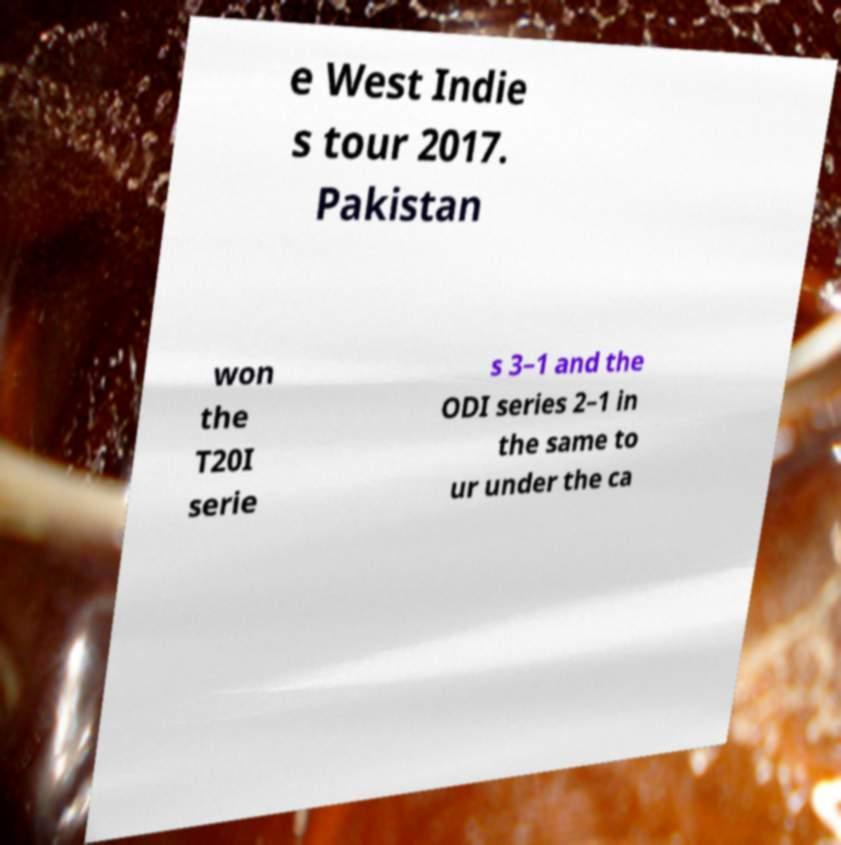What messages or text are displayed in this image? I need them in a readable, typed format. e West Indie s tour 2017. Pakistan won the T20I serie s 3–1 and the ODI series 2–1 in the same to ur under the ca 